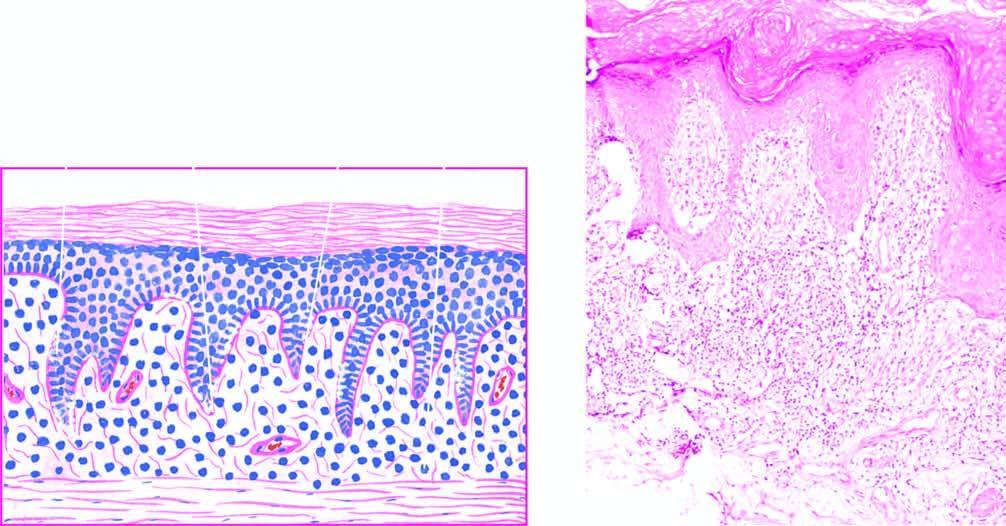does the upper dermis show a band-like mononuclear infiltrate with a sharply-demarcated lower border?
Answer the question using a single word or phrase. Yes 